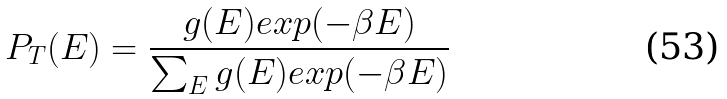<formula> <loc_0><loc_0><loc_500><loc_500>P _ { T } ( E ) = \frac { g ( E ) e x p ( - \beta E ) } { \sum _ { E } g ( E ) e x p ( - \beta E ) }</formula> 